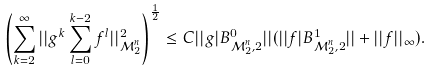<formula> <loc_0><loc_0><loc_500><loc_500>\left ( \sum _ { k = 2 } ^ { \infty } | | g ^ { k } \sum _ { l = 0 } ^ { k - 2 } f ^ { l } | | _ { \mathcal { M } ^ { n } _ { 2 } } ^ { 2 } \right ) ^ { \frac { 1 } { 2 } } \leq C | | g | B ^ { 0 } _ { \mathcal { M } ^ { n } _ { 2 } , 2 } | | ( | | f | B ^ { 1 } _ { \mathcal { M } ^ { n } _ { 2 } , 2 } | | + | | f | | _ { \infty } ) .</formula> 